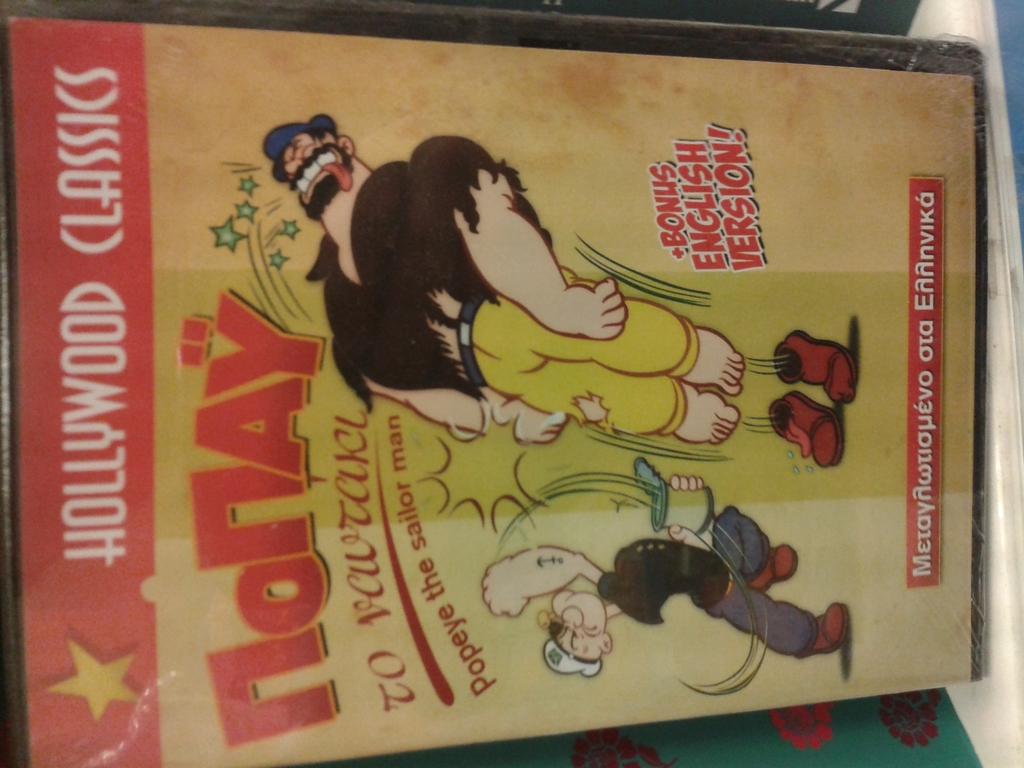Is this about popeye?
Offer a terse response. Yes. What is the title of this book?
Offer a terse response. Nonay. 